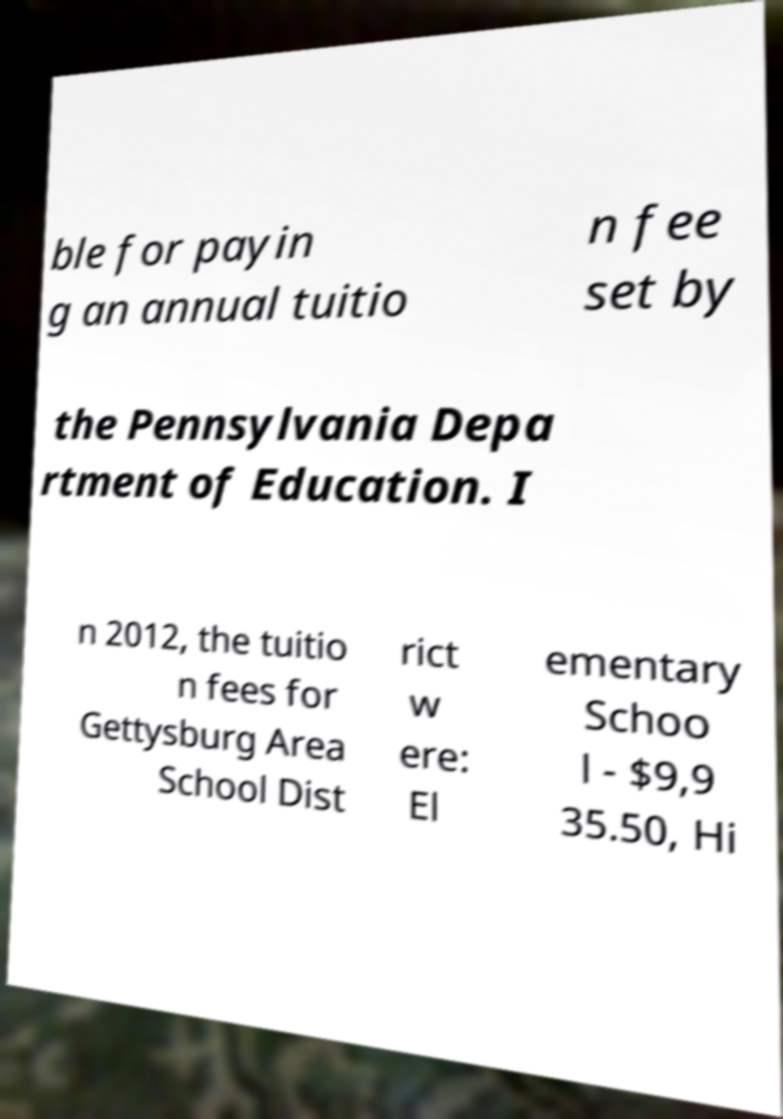Could you assist in decoding the text presented in this image and type it out clearly? ble for payin g an annual tuitio n fee set by the Pennsylvania Depa rtment of Education. I n 2012, the tuitio n fees for Gettysburg Area School Dist rict w ere: El ementary Schoo l - $9,9 35.50, Hi 